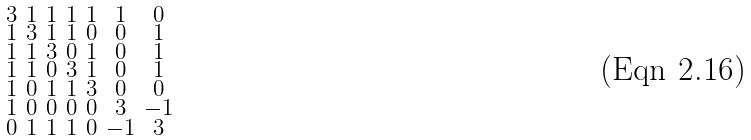<formula> <loc_0><loc_0><loc_500><loc_500>\begin{smallmatrix} 3 & 1 & 1 & 1 & 1 & 1 & 0 \\ 1 & 3 & 1 & 1 & 0 & 0 & 1 \\ 1 & 1 & 3 & 0 & 1 & 0 & 1 \\ 1 & 1 & 0 & 3 & 1 & 0 & 1 \\ 1 & 0 & 1 & 1 & 3 & 0 & 0 \\ 1 & 0 & 0 & 0 & 0 & 3 & - 1 \\ 0 & 1 & 1 & 1 & 0 & - 1 & 3 \end{smallmatrix}</formula> 